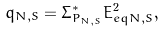<formula> <loc_0><loc_0><loc_500><loc_500>q _ { N , S } = \Sigma ^ { * } _ { P _ { N , S } } E ^ { 2 } _ { e q N , S } ,</formula> 